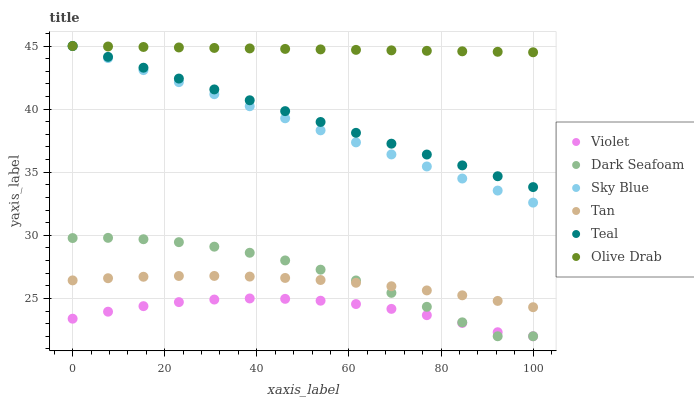Does Violet have the minimum area under the curve?
Answer yes or no. Yes. Does Olive Drab have the maximum area under the curve?
Answer yes or no. Yes. Does Teal have the minimum area under the curve?
Answer yes or no. No. Does Teal have the maximum area under the curve?
Answer yes or no. No. Is Olive Drab the smoothest?
Answer yes or no. Yes. Is Dark Seafoam the roughest?
Answer yes or no. Yes. Is Teal the smoothest?
Answer yes or no. No. Is Teal the roughest?
Answer yes or no. No. Does Dark Seafoam have the lowest value?
Answer yes or no. Yes. Does Teal have the lowest value?
Answer yes or no. No. Does Olive Drab have the highest value?
Answer yes or no. Yes. Does Violet have the highest value?
Answer yes or no. No. Is Violet less than Tan?
Answer yes or no. Yes. Is Sky Blue greater than Tan?
Answer yes or no. Yes. Does Teal intersect Sky Blue?
Answer yes or no. Yes. Is Teal less than Sky Blue?
Answer yes or no. No. Is Teal greater than Sky Blue?
Answer yes or no. No. Does Violet intersect Tan?
Answer yes or no. No. 